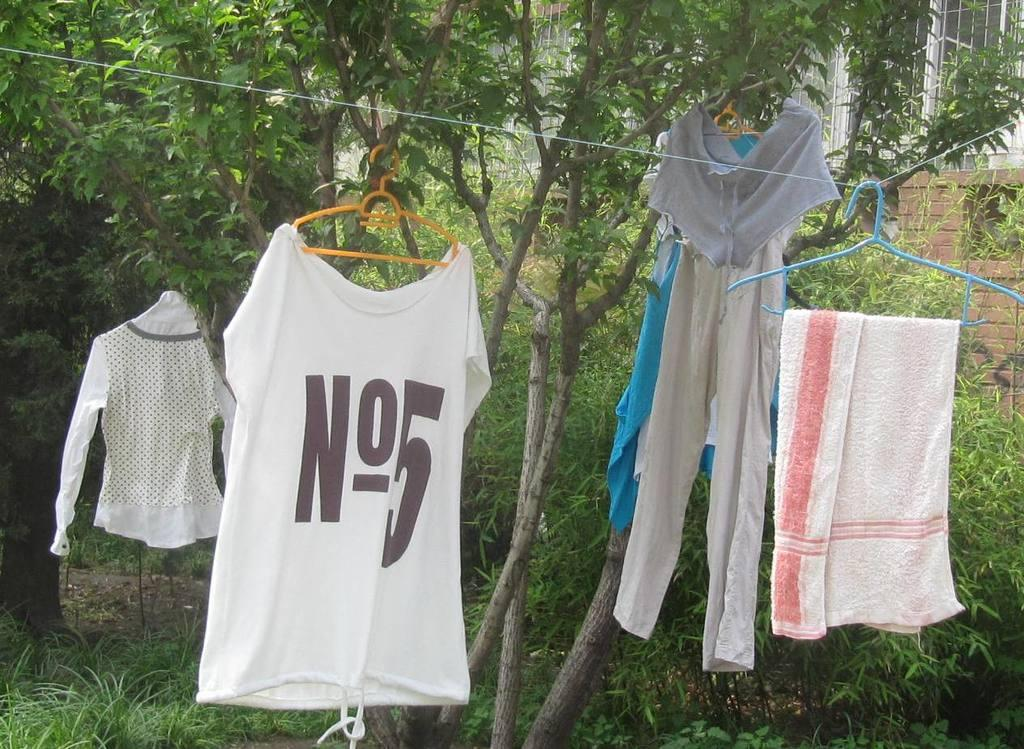Provide a one-sentence caption for the provided image. Clothes hanging outdoors with a shirt saying No.5. 